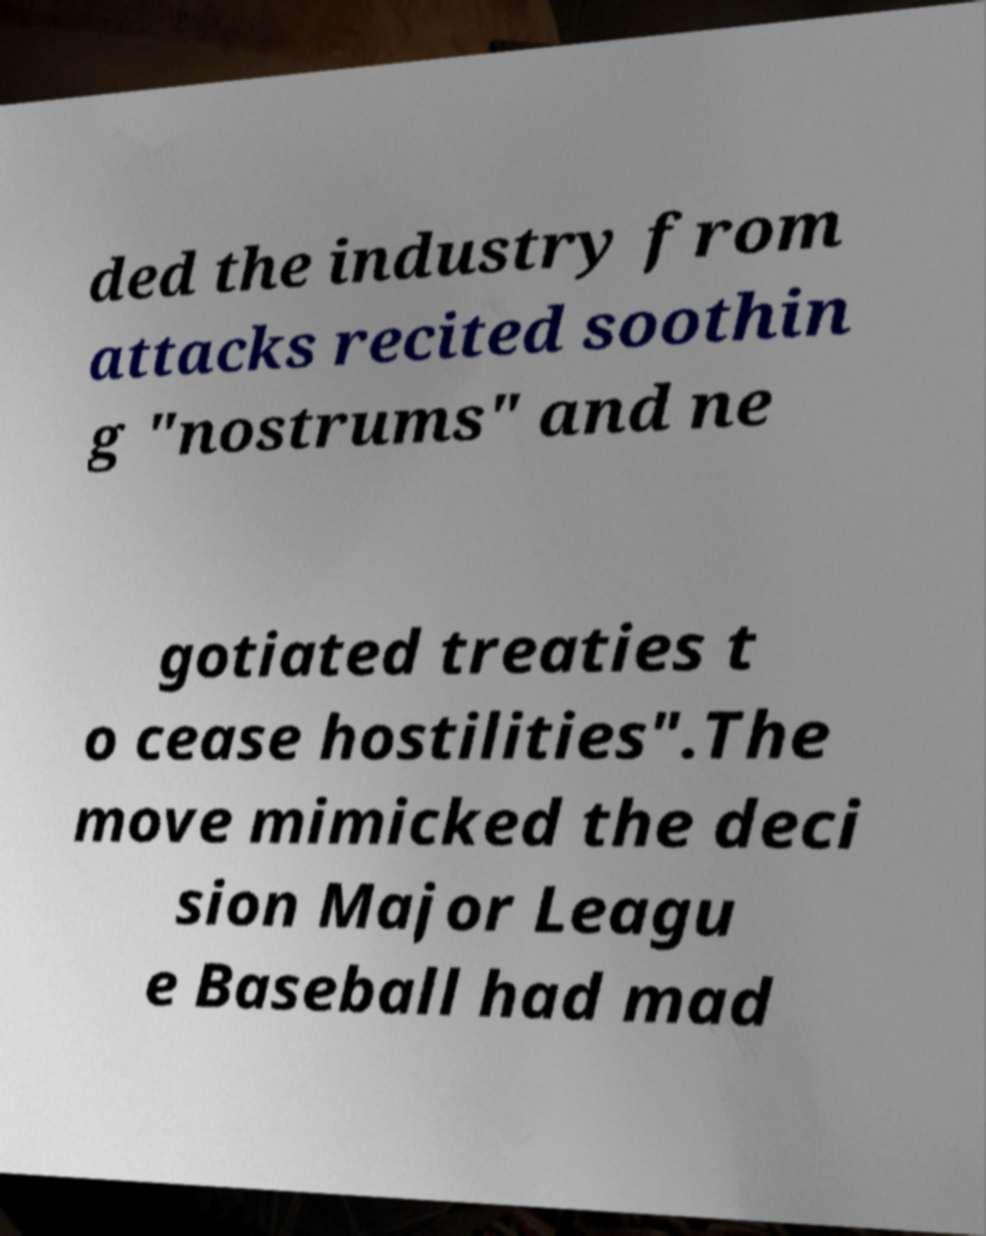Can you read and provide the text displayed in the image?This photo seems to have some interesting text. Can you extract and type it out for me? ded the industry from attacks recited soothin g "nostrums" and ne gotiated treaties t o cease hostilities".The move mimicked the deci sion Major Leagu e Baseball had mad 